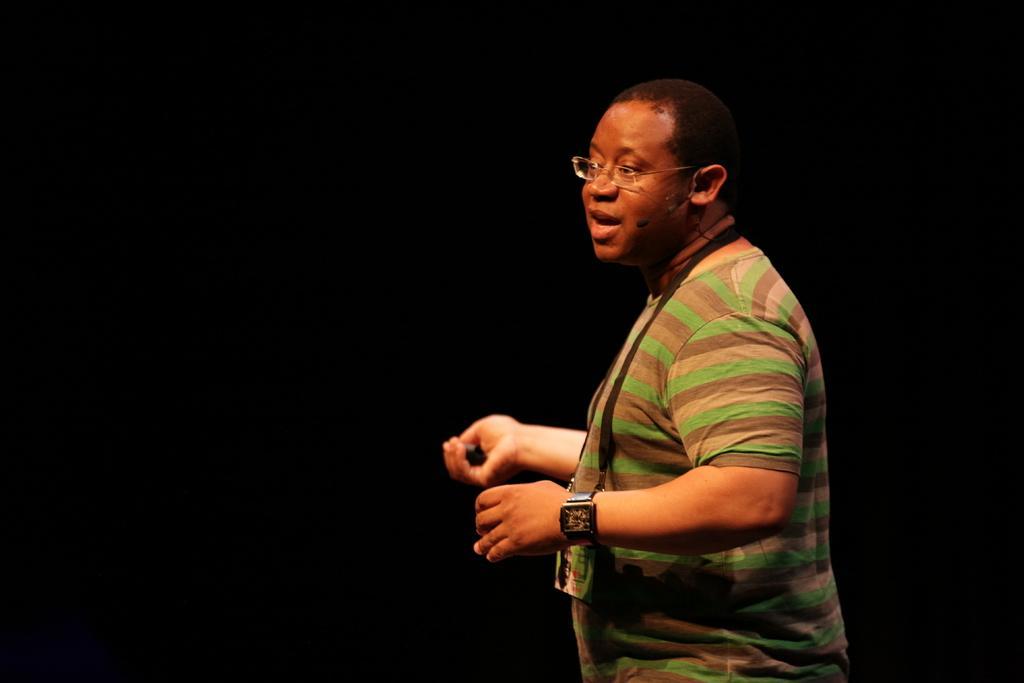Describe this image in one or two sentences. In the center of the image there is a person wearing spectacles and watch. The background of the image is black in color. 